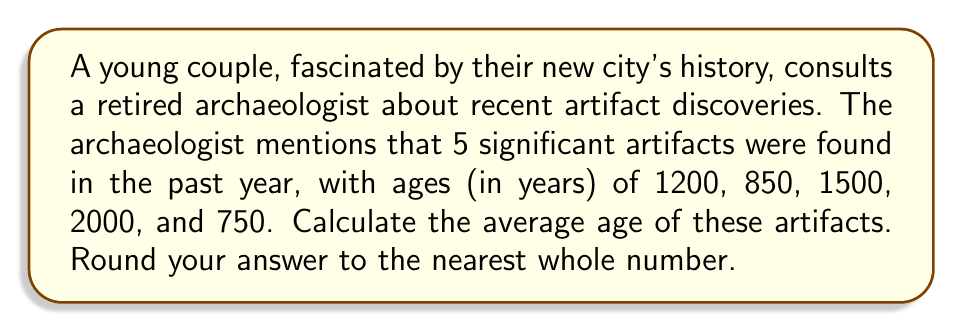What is the answer to this math problem? To calculate the average age of the artifacts, we need to follow these steps:

1. Sum up the ages of all artifacts:
   $$1200 + 850 + 1500 + 2000 + 750 = 6300$$

2. Count the total number of artifacts:
   There are 5 artifacts in total.

3. Apply the formula for arithmetic mean (average):
   $$\text{Average} = \frac{\text{Sum of all values}}{\text{Number of values}}$$

4. Substitute the values:
   $$\text{Average} = \frac{6300}{5}$$

5. Perform the division:
   $$\text{Average} = 1260$$

6. Round to the nearest whole number:
   The result is already a whole number, so no rounding is necessary.

Therefore, the average age of the artifacts is 1260 years.
Answer: 1260 years 